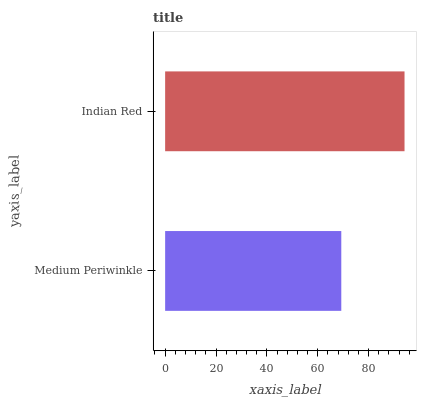Is Medium Periwinkle the minimum?
Answer yes or no. Yes. Is Indian Red the maximum?
Answer yes or no. Yes. Is Indian Red the minimum?
Answer yes or no. No. Is Indian Red greater than Medium Periwinkle?
Answer yes or no. Yes. Is Medium Periwinkle less than Indian Red?
Answer yes or no. Yes. Is Medium Periwinkle greater than Indian Red?
Answer yes or no. No. Is Indian Red less than Medium Periwinkle?
Answer yes or no. No. Is Indian Red the high median?
Answer yes or no. Yes. Is Medium Periwinkle the low median?
Answer yes or no. Yes. Is Medium Periwinkle the high median?
Answer yes or no. No. Is Indian Red the low median?
Answer yes or no. No. 